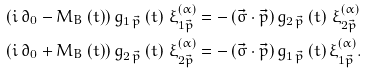Convert formula to latex. <formula><loc_0><loc_0><loc_500><loc_500>\left ( i \, \partial _ { 0 } - M _ { B } \left ( t \right ) \right ) g _ { 1 \, \vec { p } } \left ( t \right ) \, \xi _ { 1 \vec { p } } ^ { \left ( \alpha \right ) } & = - \left ( \vec { \sigma } \cdot \vec { p } \right ) g _ { 2 \, \vec { p } } \left ( t \right ) \, \xi _ { 2 \vec { p } } ^ { \left ( \alpha \right ) } \\ \left ( i \, \partial _ { 0 } + M _ { B } \left ( t \right ) \right ) g _ { 2 \, \vec { p } } \left ( t \right ) \, \xi _ { 2 \vec { p } } ^ { \left ( \alpha \right ) } & = - \left ( \vec { \sigma } \cdot \vec { p } \right ) g _ { 1 \, \vec { p } } \left ( t \right ) \xi _ { 1 \vec { p } } ^ { \left ( \alpha \right ) } .</formula> 